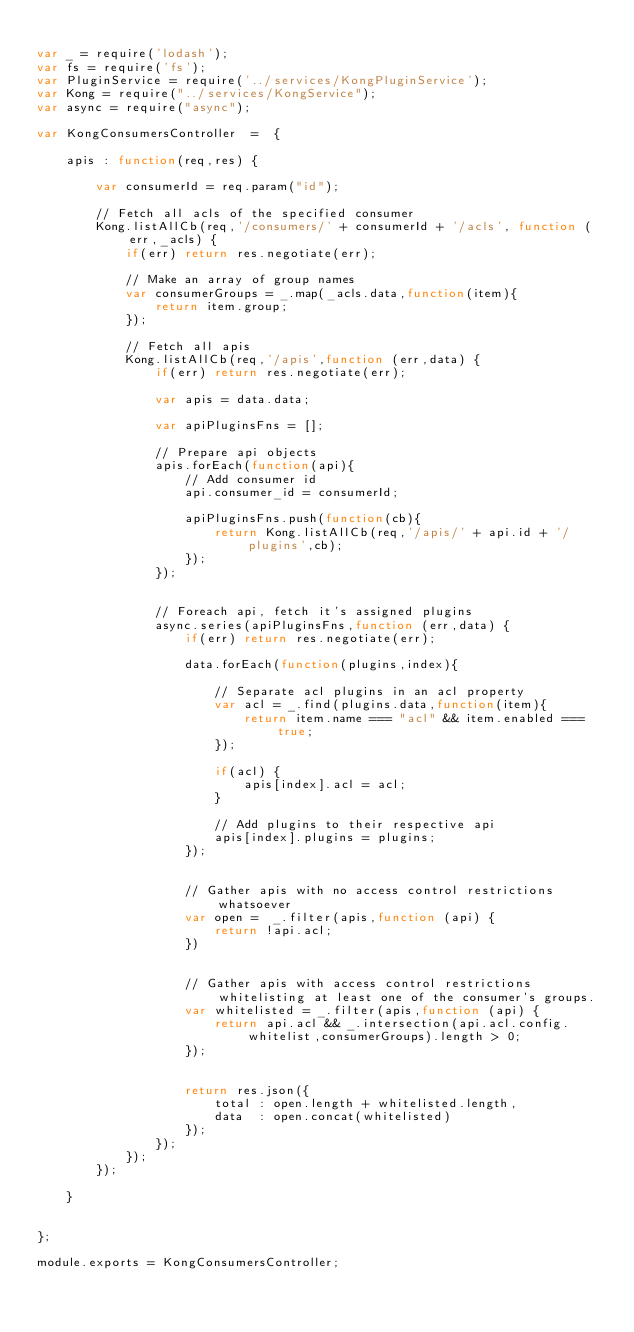Convert code to text. <code><loc_0><loc_0><loc_500><loc_500><_JavaScript_>
var _ = require('lodash');
var fs = require('fs');
var PluginService = require('../services/KongPluginService');
var Kong = require("../services/KongService");
var async = require("async");

var KongConsumersController  =  {

    apis : function(req,res) {

        var consumerId = req.param("id");

        // Fetch all acls of the specified consumer
        Kong.listAllCb(req,'/consumers/' + consumerId + '/acls', function (err,_acls) {
            if(err) return res.negotiate(err);

            // Make an array of group names
            var consumerGroups = _.map(_acls.data,function(item){
                return item.group;
            });

            // Fetch all apis
            Kong.listAllCb(req,'/apis',function (err,data) {
                if(err) return res.negotiate(err);

                var apis = data.data;

                var apiPluginsFns = [];

                // Prepare api objects
                apis.forEach(function(api){
                    // Add consumer id
                    api.consumer_id = consumerId;

                    apiPluginsFns.push(function(cb){
                        return Kong.listAllCb(req,'/apis/' + api.id + '/plugins',cb);
                    });
                });


                // Foreach api, fetch it's assigned plugins
                async.series(apiPluginsFns,function (err,data) {
                    if(err) return res.negotiate(err);

                    data.forEach(function(plugins,index){

                        // Separate acl plugins in an acl property
                        var acl = _.find(plugins.data,function(item){
                            return item.name === "acl" && item.enabled === true;
                        });

                        if(acl) {
                            apis[index].acl = acl;
                        }

                        // Add plugins to their respective api
                        apis[index].plugins = plugins;
                    });


                    // Gather apis with no access control restrictions whatsoever
                    var open =  _.filter(apis,function (api) {
                        return !api.acl;
                    })


                    // Gather apis with access control restrictions whitelisting at least one of the consumer's groups.
                    var whitelisted = _.filter(apis,function (api) {
                        return api.acl && _.intersection(api.acl.config.whitelist,consumerGroups).length > 0;
                    });


                    return res.json({
                        total : open.length + whitelisted.length,
                        data  : open.concat(whitelisted)
                    });
                });
            });
        });

    }


};

module.exports = KongConsumersController;
</code> 